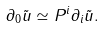<formula> <loc_0><loc_0><loc_500><loc_500>\partial _ { 0 } \tilde { u } \simeq P ^ { i } \partial _ { i } \tilde { u } .</formula> 